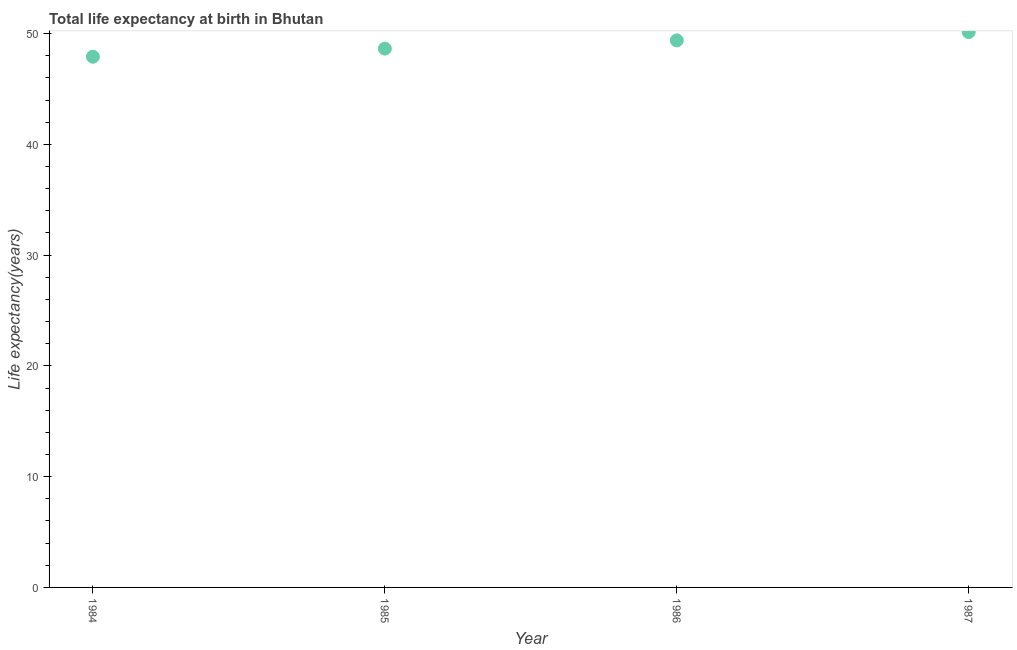What is the life expectancy at birth in 1986?
Make the answer very short. 49.38. Across all years, what is the maximum life expectancy at birth?
Your answer should be very brief. 50.13. Across all years, what is the minimum life expectancy at birth?
Offer a very short reply. 47.91. In which year was the life expectancy at birth maximum?
Your response must be concise. 1987. What is the sum of the life expectancy at birth?
Keep it short and to the point. 196.06. What is the difference between the life expectancy at birth in 1985 and 1986?
Give a very brief answer. -0.74. What is the average life expectancy at birth per year?
Provide a succinct answer. 49.02. What is the median life expectancy at birth?
Offer a very short reply. 49.01. In how many years, is the life expectancy at birth greater than 20 years?
Offer a terse response. 4. What is the ratio of the life expectancy at birth in 1986 to that in 1987?
Give a very brief answer. 0.98. What is the difference between the highest and the second highest life expectancy at birth?
Provide a succinct answer. 0.75. Is the sum of the life expectancy at birth in 1985 and 1987 greater than the maximum life expectancy at birth across all years?
Offer a very short reply. Yes. What is the difference between the highest and the lowest life expectancy at birth?
Ensure brevity in your answer.  2.23. In how many years, is the life expectancy at birth greater than the average life expectancy at birth taken over all years?
Your answer should be compact. 2. Does the life expectancy at birth monotonically increase over the years?
Ensure brevity in your answer.  Yes. How many dotlines are there?
Offer a terse response. 1. How many years are there in the graph?
Give a very brief answer. 4. Does the graph contain grids?
Keep it short and to the point. No. What is the title of the graph?
Provide a succinct answer. Total life expectancy at birth in Bhutan. What is the label or title of the Y-axis?
Offer a terse response. Life expectancy(years). What is the Life expectancy(years) in 1984?
Ensure brevity in your answer.  47.91. What is the Life expectancy(years) in 1985?
Ensure brevity in your answer.  48.64. What is the Life expectancy(years) in 1986?
Your answer should be very brief. 49.38. What is the Life expectancy(years) in 1987?
Keep it short and to the point. 50.13. What is the difference between the Life expectancy(years) in 1984 and 1985?
Give a very brief answer. -0.73. What is the difference between the Life expectancy(years) in 1984 and 1986?
Provide a succinct answer. -1.47. What is the difference between the Life expectancy(years) in 1984 and 1987?
Your response must be concise. -2.23. What is the difference between the Life expectancy(years) in 1985 and 1986?
Ensure brevity in your answer.  -0.74. What is the difference between the Life expectancy(years) in 1985 and 1987?
Your answer should be compact. -1.49. What is the difference between the Life expectancy(years) in 1986 and 1987?
Ensure brevity in your answer.  -0.75. What is the ratio of the Life expectancy(years) in 1984 to that in 1985?
Provide a short and direct response. 0.98. What is the ratio of the Life expectancy(years) in 1984 to that in 1986?
Ensure brevity in your answer.  0.97. What is the ratio of the Life expectancy(years) in 1984 to that in 1987?
Your answer should be compact. 0.96. What is the ratio of the Life expectancy(years) in 1985 to that in 1986?
Your answer should be compact. 0.98. What is the ratio of the Life expectancy(years) in 1985 to that in 1987?
Ensure brevity in your answer.  0.97. What is the ratio of the Life expectancy(years) in 1986 to that in 1987?
Your answer should be compact. 0.98. 